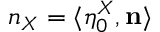<formula> <loc_0><loc_0><loc_500><loc_500>n _ { X } = \langle \eta _ { 0 } ^ { X } , n \rangle</formula> 